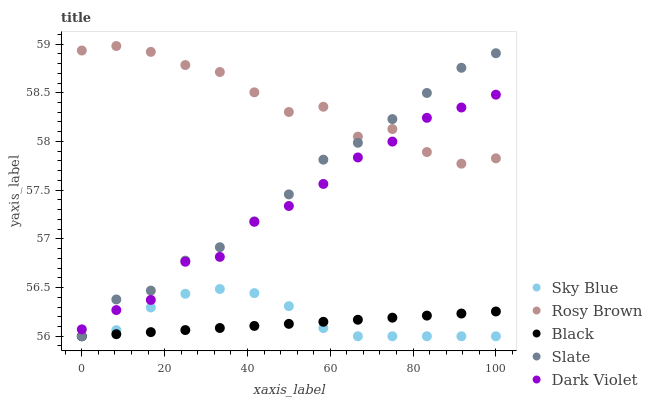Does Black have the minimum area under the curve?
Answer yes or no. Yes. Does Rosy Brown have the maximum area under the curve?
Answer yes or no. Yes. Does Slate have the minimum area under the curve?
Answer yes or no. No. Does Slate have the maximum area under the curve?
Answer yes or no. No. Is Black the smoothest?
Answer yes or no. Yes. Is Rosy Brown the roughest?
Answer yes or no. Yes. Is Slate the smoothest?
Answer yes or no. No. Is Slate the roughest?
Answer yes or no. No. Does Sky Blue have the lowest value?
Answer yes or no. Yes. Does Rosy Brown have the lowest value?
Answer yes or no. No. Does Rosy Brown have the highest value?
Answer yes or no. Yes. Does Slate have the highest value?
Answer yes or no. No. Is Sky Blue less than Rosy Brown?
Answer yes or no. Yes. Is Dark Violet greater than Sky Blue?
Answer yes or no. Yes. Does Black intersect Sky Blue?
Answer yes or no. Yes. Is Black less than Sky Blue?
Answer yes or no. No. Is Black greater than Sky Blue?
Answer yes or no. No. Does Sky Blue intersect Rosy Brown?
Answer yes or no. No. 